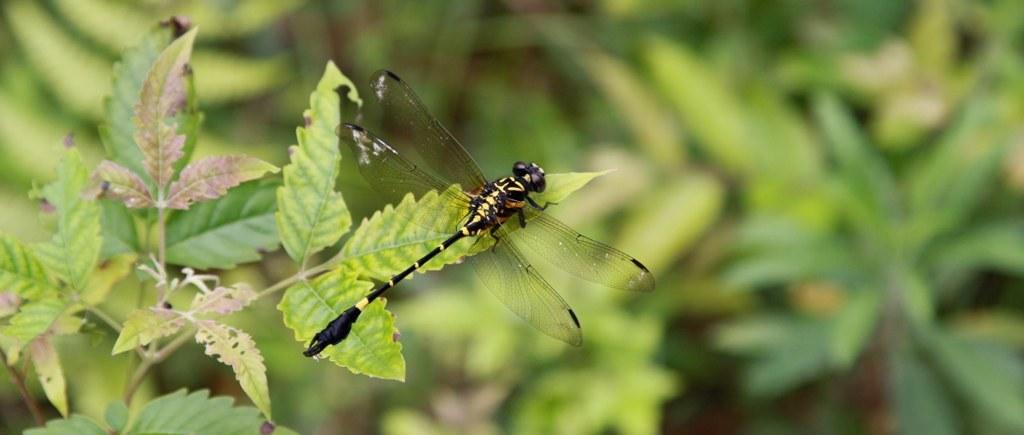What is present on the leaf in the image? There is an insect on the leaf in the image. What type of plant does the leaf belong to? The leaf belongs to a plant, but the specific type of plant is not mentioned in the facts. What can be seen in the background of the image? The background of the image consists of greenery. How many friends does the insect have in the image? There is no information about friends in the image, as it only shows an insect on a leaf. 